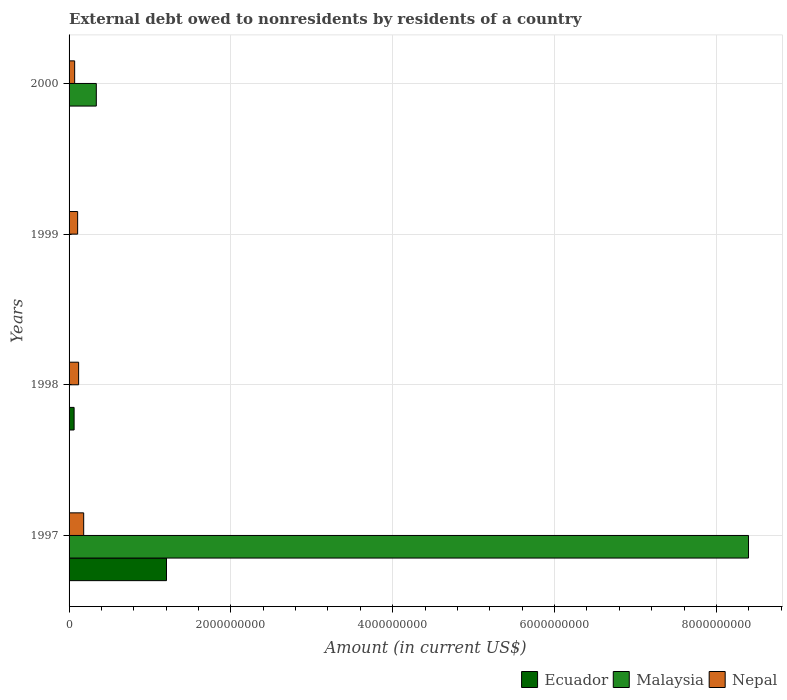How many different coloured bars are there?
Your answer should be compact. 3. In how many cases, is the number of bars for a given year not equal to the number of legend labels?
Keep it short and to the point. 3. Across all years, what is the maximum external debt owed by residents in Ecuador?
Your response must be concise. 1.20e+09. Across all years, what is the minimum external debt owed by residents in Nepal?
Offer a terse response. 6.90e+07. What is the total external debt owed by residents in Nepal in the graph?
Give a very brief answer. 4.74e+08. What is the difference between the external debt owed by residents in Ecuador in 1997 and that in 1998?
Give a very brief answer. 1.14e+09. What is the difference between the external debt owed by residents in Ecuador in 2000 and the external debt owed by residents in Nepal in 1999?
Offer a very short reply. -1.06e+08. What is the average external debt owed by residents in Nepal per year?
Offer a terse response. 1.18e+08. In the year 1997, what is the difference between the external debt owed by residents in Malaysia and external debt owed by residents in Nepal?
Make the answer very short. 8.22e+09. What is the ratio of the external debt owed by residents in Nepal in 1998 to that in 1999?
Offer a very short reply. 1.12. Is the difference between the external debt owed by residents in Malaysia in 1997 and 2000 greater than the difference between the external debt owed by residents in Nepal in 1997 and 2000?
Keep it short and to the point. Yes. What is the difference between the highest and the second highest external debt owed by residents in Nepal?
Make the answer very short. 6.25e+07. What is the difference between the highest and the lowest external debt owed by residents in Malaysia?
Your answer should be very brief. 8.40e+09. In how many years, is the external debt owed by residents in Nepal greater than the average external debt owed by residents in Nepal taken over all years?
Make the answer very short. 1. Is the sum of the external debt owed by residents in Malaysia in 1997 and 2000 greater than the maximum external debt owed by residents in Nepal across all years?
Keep it short and to the point. Yes. Is it the case that in every year, the sum of the external debt owed by residents in Malaysia and external debt owed by residents in Nepal is greater than the external debt owed by residents in Ecuador?
Your response must be concise. Yes. Are all the bars in the graph horizontal?
Keep it short and to the point. Yes. Are the values on the major ticks of X-axis written in scientific E-notation?
Provide a succinct answer. No. Does the graph contain any zero values?
Provide a succinct answer. Yes. What is the title of the graph?
Make the answer very short. External debt owed to nonresidents by residents of a country. Does "Tuvalu" appear as one of the legend labels in the graph?
Ensure brevity in your answer.  No. What is the Amount (in current US$) in Ecuador in 1997?
Your answer should be compact. 1.20e+09. What is the Amount (in current US$) of Malaysia in 1997?
Your response must be concise. 8.40e+09. What is the Amount (in current US$) in Nepal in 1997?
Make the answer very short. 1.81e+08. What is the Amount (in current US$) in Ecuador in 1998?
Offer a terse response. 6.22e+07. What is the Amount (in current US$) of Nepal in 1998?
Offer a very short reply. 1.18e+08. What is the Amount (in current US$) in Nepal in 1999?
Give a very brief answer. 1.06e+08. What is the Amount (in current US$) of Ecuador in 2000?
Provide a succinct answer. 0. What is the Amount (in current US$) of Malaysia in 2000?
Provide a succinct answer. 3.37e+08. What is the Amount (in current US$) of Nepal in 2000?
Keep it short and to the point. 6.90e+07. Across all years, what is the maximum Amount (in current US$) of Ecuador?
Give a very brief answer. 1.20e+09. Across all years, what is the maximum Amount (in current US$) of Malaysia?
Provide a short and direct response. 8.40e+09. Across all years, what is the maximum Amount (in current US$) of Nepal?
Keep it short and to the point. 1.81e+08. Across all years, what is the minimum Amount (in current US$) of Malaysia?
Your answer should be compact. 0. Across all years, what is the minimum Amount (in current US$) of Nepal?
Give a very brief answer. 6.90e+07. What is the total Amount (in current US$) of Ecuador in the graph?
Your response must be concise. 1.27e+09. What is the total Amount (in current US$) of Malaysia in the graph?
Provide a succinct answer. 8.73e+09. What is the total Amount (in current US$) in Nepal in the graph?
Make the answer very short. 4.74e+08. What is the difference between the Amount (in current US$) of Ecuador in 1997 and that in 1998?
Provide a succinct answer. 1.14e+09. What is the difference between the Amount (in current US$) in Nepal in 1997 and that in 1998?
Your answer should be very brief. 6.25e+07. What is the difference between the Amount (in current US$) in Nepal in 1997 and that in 1999?
Keep it short and to the point. 7.48e+07. What is the difference between the Amount (in current US$) of Malaysia in 1997 and that in 2000?
Ensure brevity in your answer.  8.06e+09. What is the difference between the Amount (in current US$) of Nepal in 1997 and that in 2000?
Provide a short and direct response. 1.12e+08. What is the difference between the Amount (in current US$) in Nepal in 1998 and that in 1999?
Give a very brief answer. 1.23e+07. What is the difference between the Amount (in current US$) in Nepal in 1998 and that in 2000?
Your answer should be very brief. 4.91e+07. What is the difference between the Amount (in current US$) of Nepal in 1999 and that in 2000?
Provide a short and direct response. 3.68e+07. What is the difference between the Amount (in current US$) in Ecuador in 1997 and the Amount (in current US$) in Nepal in 1998?
Give a very brief answer. 1.09e+09. What is the difference between the Amount (in current US$) of Malaysia in 1997 and the Amount (in current US$) of Nepal in 1998?
Your response must be concise. 8.28e+09. What is the difference between the Amount (in current US$) in Ecuador in 1997 and the Amount (in current US$) in Nepal in 1999?
Offer a very short reply. 1.10e+09. What is the difference between the Amount (in current US$) of Malaysia in 1997 and the Amount (in current US$) of Nepal in 1999?
Keep it short and to the point. 8.29e+09. What is the difference between the Amount (in current US$) in Ecuador in 1997 and the Amount (in current US$) in Malaysia in 2000?
Ensure brevity in your answer.  8.68e+08. What is the difference between the Amount (in current US$) of Ecuador in 1997 and the Amount (in current US$) of Nepal in 2000?
Your answer should be compact. 1.14e+09. What is the difference between the Amount (in current US$) in Malaysia in 1997 and the Amount (in current US$) in Nepal in 2000?
Provide a short and direct response. 8.33e+09. What is the difference between the Amount (in current US$) in Ecuador in 1998 and the Amount (in current US$) in Nepal in 1999?
Give a very brief answer. -4.36e+07. What is the difference between the Amount (in current US$) in Ecuador in 1998 and the Amount (in current US$) in Malaysia in 2000?
Your response must be concise. -2.74e+08. What is the difference between the Amount (in current US$) in Ecuador in 1998 and the Amount (in current US$) in Nepal in 2000?
Your answer should be very brief. -6.78e+06. What is the average Amount (in current US$) of Ecuador per year?
Make the answer very short. 3.17e+08. What is the average Amount (in current US$) of Malaysia per year?
Provide a short and direct response. 2.18e+09. What is the average Amount (in current US$) in Nepal per year?
Your answer should be very brief. 1.18e+08. In the year 1997, what is the difference between the Amount (in current US$) of Ecuador and Amount (in current US$) of Malaysia?
Offer a terse response. -7.19e+09. In the year 1997, what is the difference between the Amount (in current US$) of Ecuador and Amount (in current US$) of Nepal?
Provide a short and direct response. 1.02e+09. In the year 1997, what is the difference between the Amount (in current US$) in Malaysia and Amount (in current US$) in Nepal?
Give a very brief answer. 8.22e+09. In the year 1998, what is the difference between the Amount (in current US$) in Ecuador and Amount (in current US$) in Nepal?
Offer a very short reply. -5.59e+07. In the year 2000, what is the difference between the Amount (in current US$) in Malaysia and Amount (in current US$) in Nepal?
Your response must be concise. 2.68e+08. What is the ratio of the Amount (in current US$) of Ecuador in 1997 to that in 1998?
Make the answer very short. 19.35. What is the ratio of the Amount (in current US$) of Nepal in 1997 to that in 1998?
Your answer should be very brief. 1.53. What is the ratio of the Amount (in current US$) in Nepal in 1997 to that in 1999?
Make the answer very short. 1.71. What is the ratio of the Amount (in current US$) of Malaysia in 1997 to that in 2000?
Give a very brief answer. 24.94. What is the ratio of the Amount (in current US$) in Nepal in 1997 to that in 2000?
Offer a terse response. 2.62. What is the ratio of the Amount (in current US$) in Nepal in 1998 to that in 1999?
Your answer should be compact. 1.12. What is the ratio of the Amount (in current US$) in Nepal in 1998 to that in 2000?
Your answer should be very brief. 1.71. What is the ratio of the Amount (in current US$) in Nepal in 1999 to that in 2000?
Offer a terse response. 1.53. What is the difference between the highest and the second highest Amount (in current US$) in Nepal?
Offer a very short reply. 6.25e+07. What is the difference between the highest and the lowest Amount (in current US$) in Ecuador?
Provide a succinct answer. 1.20e+09. What is the difference between the highest and the lowest Amount (in current US$) in Malaysia?
Give a very brief answer. 8.40e+09. What is the difference between the highest and the lowest Amount (in current US$) in Nepal?
Offer a very short reply. 1.12e+08. 